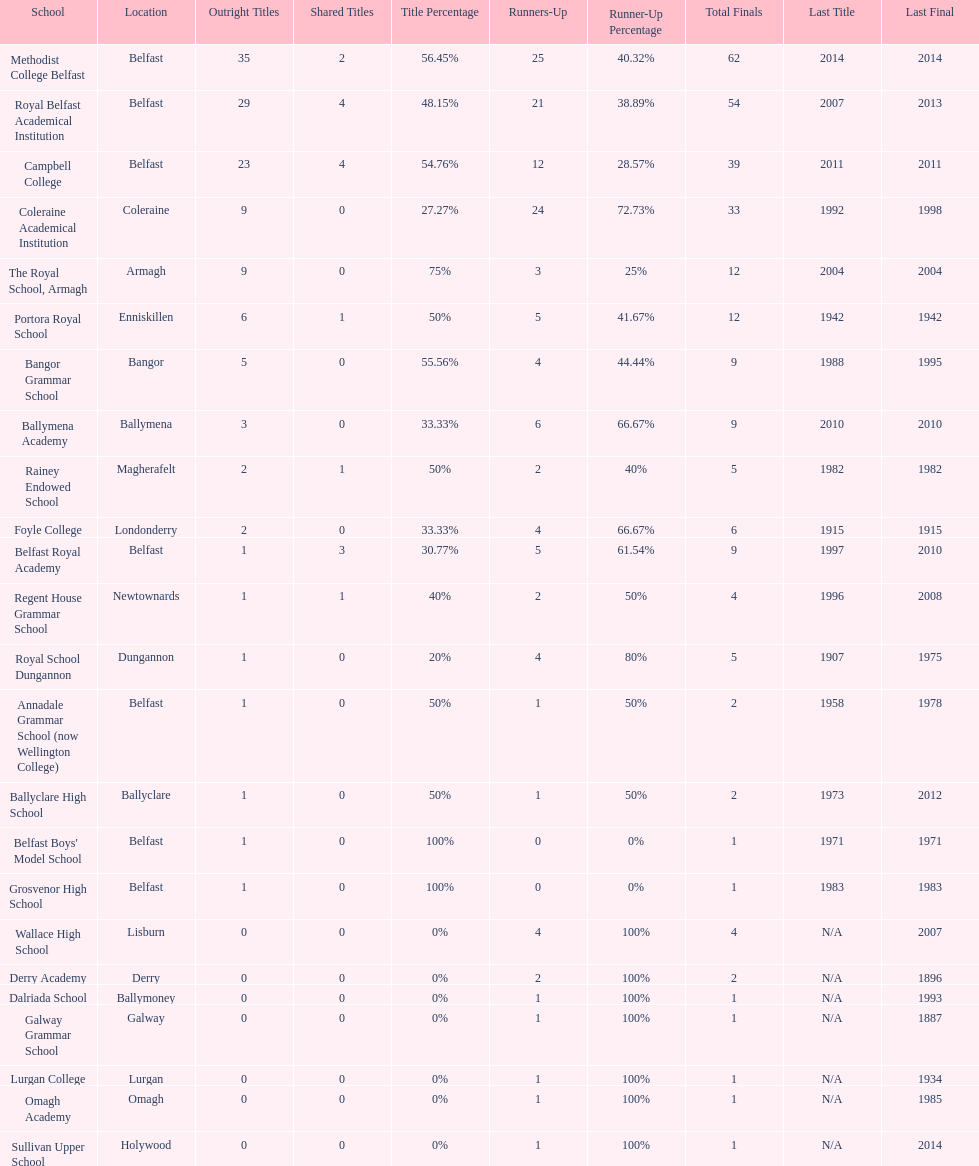What number of total finals does foyle college have? 6. 